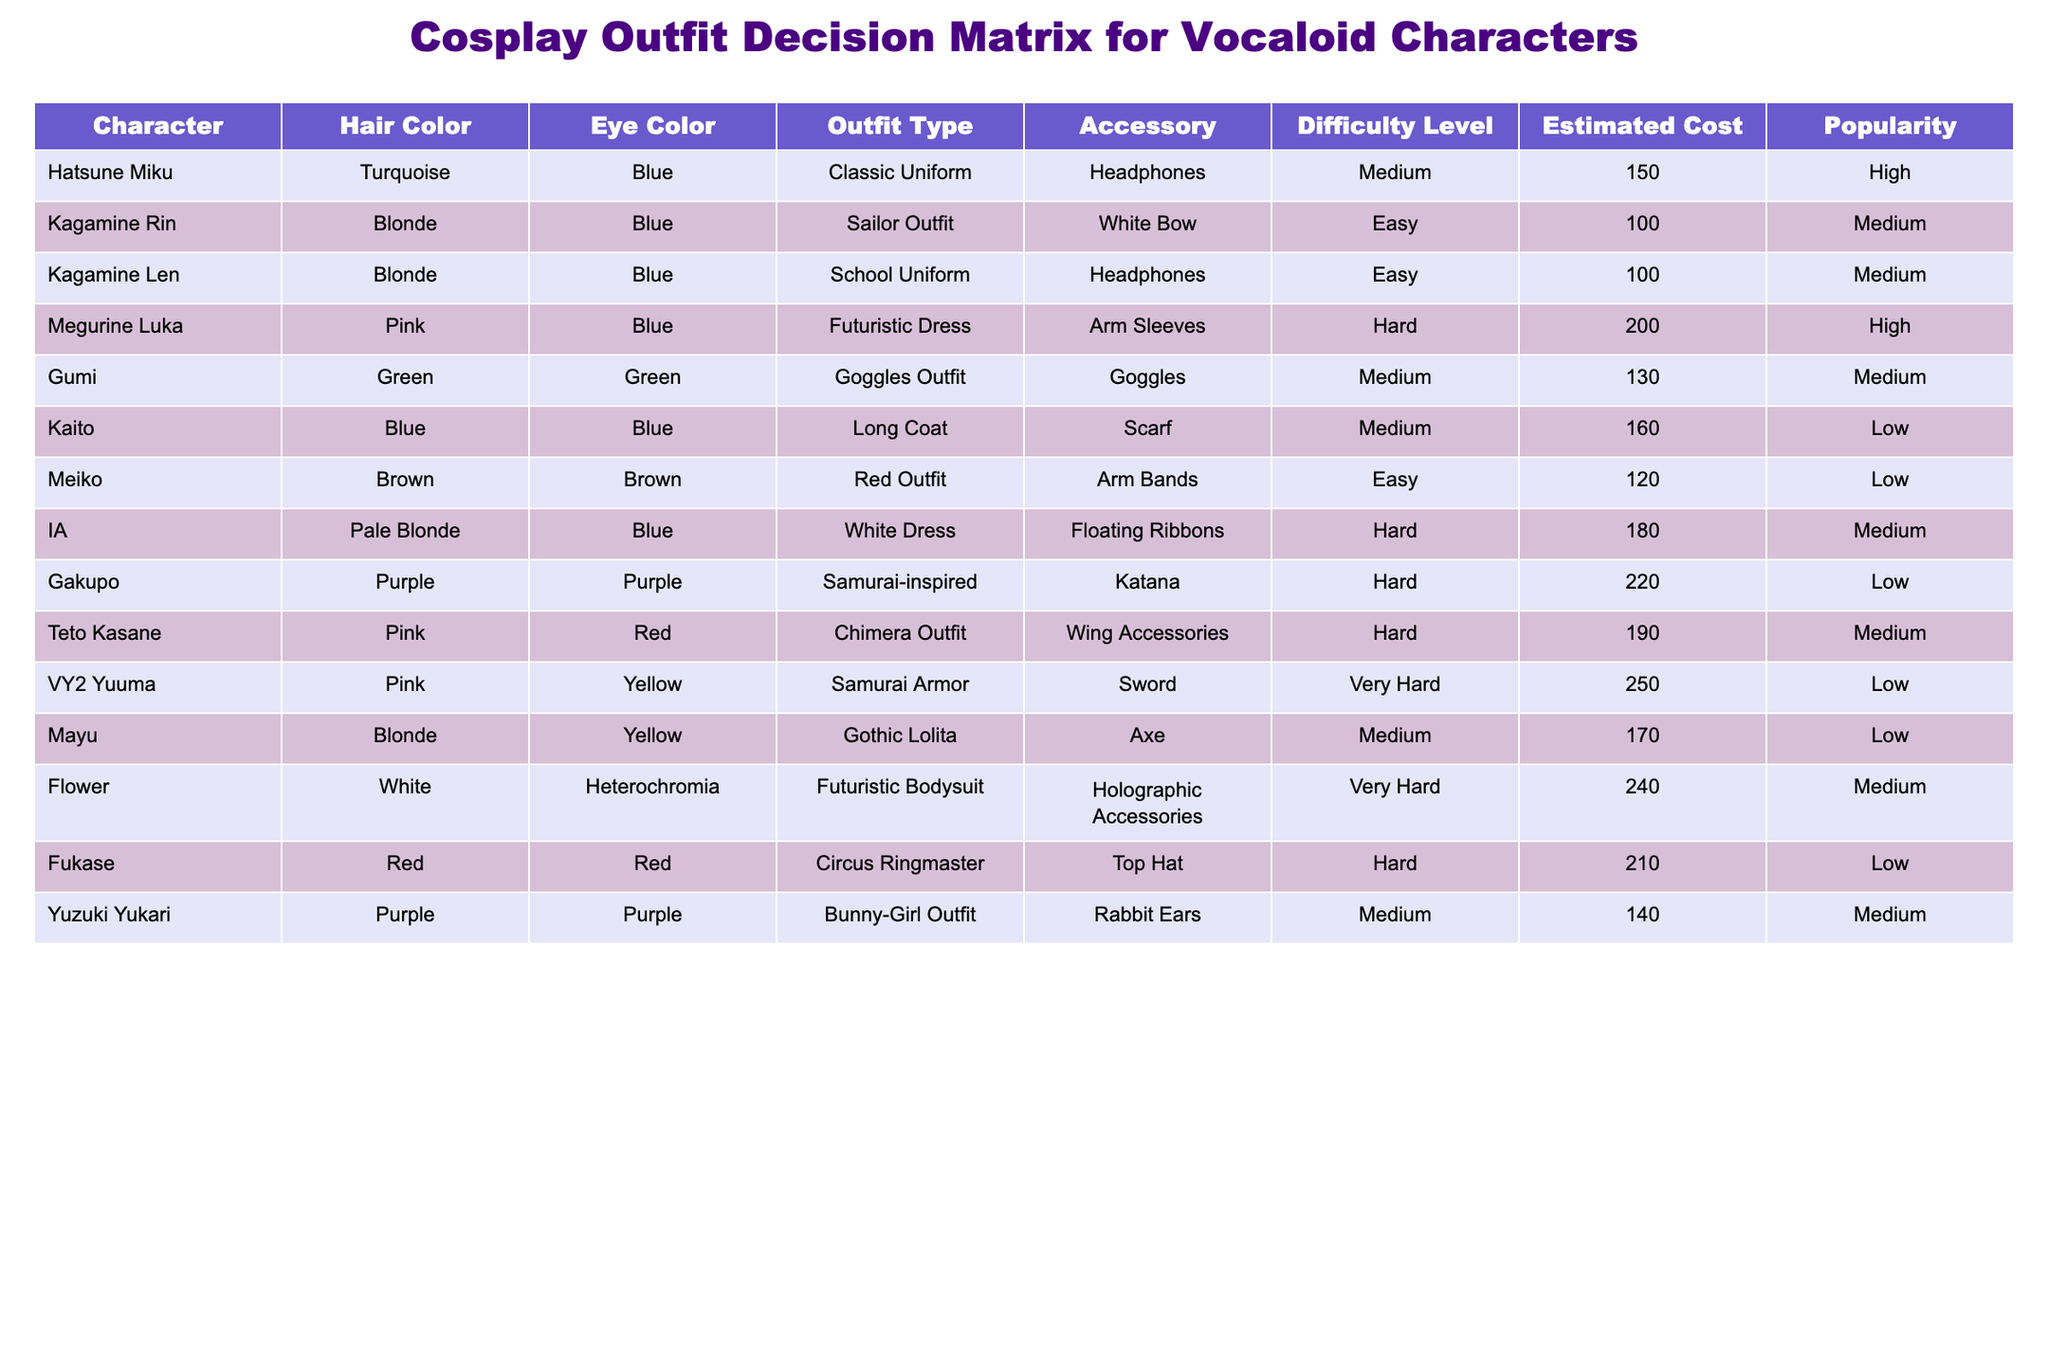What is the difficulty level of the outfit for Hatsune Miku? The table lists Hatsune Miku under the "Difficulty Level" column, which shows "Medium" for her outfit.
Answer: Medium How many characters have a popularity rating of "High"? By reviewing the "Popularity" column, I can identify that both Hatsune Miku and Megurine Luka have a popularity rating of "High". Therefore, there are 2 characters in total.
Answer: 2 Which character has the highest estimated cost for their outfit? Checking the "Estimated Cost" column, Gakupo has the highest estimated cost of 220 compared to other characters.
Answer: Gakupo What is the average estimated cost of the characters with a difficulty level of "Easy"? The estimated costs for characters with "Easy" difficulty are 100 (Kagamine Rin) + 100 (Kagamine Len) + 120 (Meiko) = 320. The average is 320 divided by 3, resulting in approximately 106.67.
Answer: 106.67 Is there any character whose outfit type is "Bunny-Girl Outfit"? Examining the "Outfit Type" column, I find that Yuzuki Yukari is the only character listed with the "Bunny-Girl Outfit".
Answer: Yes Which character has a pink hair color and what is their outfit type? The characters with pink hair color are Megurine Luka, Teto Kasane, and VY2 Yuuma. Their outfit types are "Futuristic Dress", "Chimera Outfit", and "Samurai Armor" respectively.
Answer: Megurine Luka, Futuristic Dress; Teto Kasane, Chimera Outfit; VY2 Yuuma, Samurai Armor Total how many characters have a hair color of "Blonde"? By checking the "Hair Color" column, I see that Kagamine Rin and Kagamine Len as well as Mayu are the characters listed with the hair color "Blonde." Therefore, there are 3 characters in total.
Answer: 3 What percentage of characters have an estimated cost that is less than 150? The characters with an estimated cost less than 150 are Kagamine Rin (100), Kagamine Len (100), Gumi (130), and Yuzuki Yukari (140), which makes a total of 4 characters. There are 12 characters overall, resulting in a percentage of (4/12)*100 = 33.33%.
Answer: 33.33% 